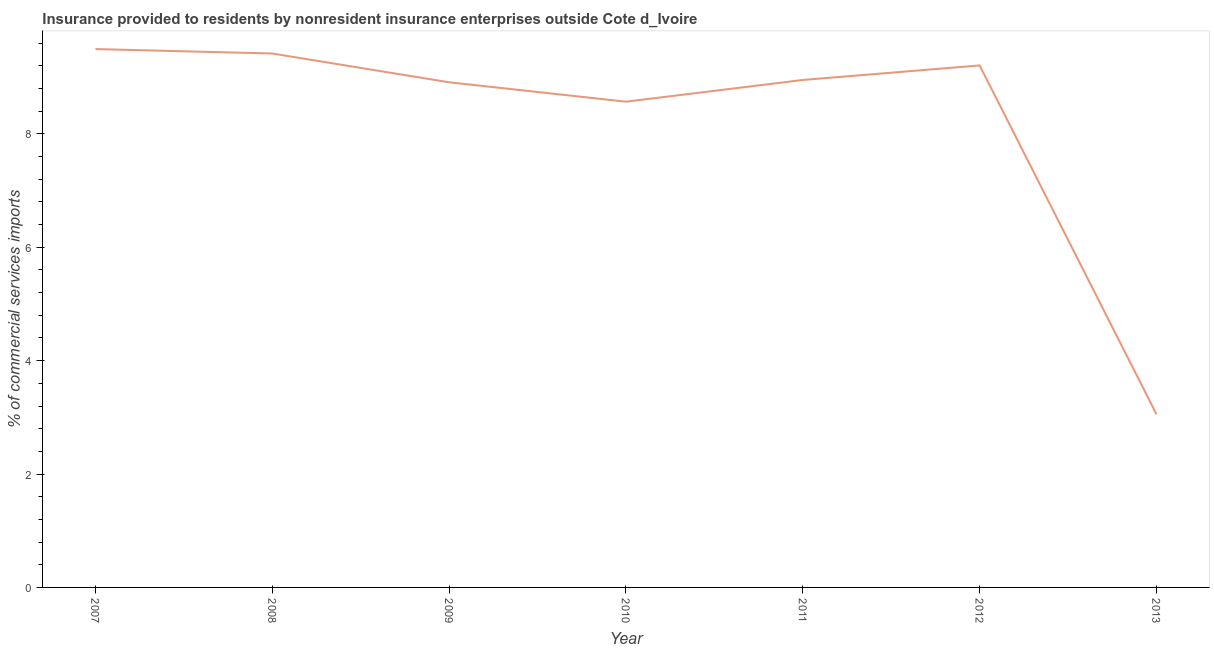What is the insurance provided by non-residents in 2011?
Provide a short and direct response. 8.95. Across all years, what is the maximum insurance provided by non-residents?
Provide a succinct answer. 9.5. Across all years, what is the minimum insurance provided by non-residents?
Your answer should be compact. 3.05. What is the sum of the insurance provided by non-residents?
Give a very brief answer. 57.6. What is the difference between the insurance provided by non-residents in 2010 and 2013?
Offer a very short reply. 5.51. What is the average insurance provided by non-residents per year?
Give a very brief answer. 8.23. What is the median insurance provided by non-residents?
Offer a terse response. 8.95. Do a majority of the years between 2007 and 2008 (inclusive) have insurance provided by non-residents greater than 4 %?
Provide a short and direct response. Yes. What is the ratio of the insurance provided by non-residents in 2007 to that in 2011?
Keep it short and to the point. 1.06. Is the difference between the insurance provided by non-residents in 2007 and 2013 greater than the difference between any two years?
Offer a very short reply. Yes. What is the difference between the highest and the second highest insurance provided by non-residents?
Your answer should be compact. 0.08. What is the difference between the highest and the lowest insurance provided by non-residents?
Offer a very short reply. 6.44. In how many years, is the insurance provided by non-residents greater than the average insurance provided by non-residents taken over all years?
Provide a succinct answer. 6. How many years are there in the graph?
Ensure brevity in your answer.  7. Are the values on the major ticks of Y-axis written in scientific E-notation?
Keep it short and to the point. No. Does the graph contain any zero values?
Keep it short and to the point. No. What is the title of the graph?
Provide a short and direct response. Insurance provided to residents by nonresident insurance enterprises outside Cote d_Ivoire. What is the label or title of the X-axis?
Your answer should be compact. Year. What is the label or title of the Y-axis?
Provide a short and direct response. % of commercial services imports. What is the % of commercial services imports of 2007?
Keep it short and to the point. 9.5. What is the % of commercial services imports of 2008?
Provide a succinct answer. 9.42. What is the % of commercial services imports of 2009?
Provide a short and direct response. 8.91. What is the % of commercial services imports of 2010?
Offer a terse response. 8.57. What is the % of commercial services imports of 2011?
Your answer should be compact. 8.95. What is the % of commercial services imports of 2012?
Your response must be concise. 9.21. What is the % of commercial services imports in 2013?
Your answer should be very brief. 3.05. What is the difference between the % of commercial services imports in 2007 and 2008?
Your response must be concise. 0.08. What is the difference between the % of commercial services imports in 2007 and 2009?
Provide a short and direct response. 0.59. What is the difference between the % of commercial services imports in 2007 and 2010?
Make the answer very short. 0.93. What is the difference between the % of commercial services imports in 2007 and 2011?
Your response must be concise. 0.54. What is the difference between the % of commercial services imports in 2007 and 2012?
Your answer should be very brief. 0.29. What is the difference between the % of commercial services imports in 2007 and 2013?
Offer a terse response. 6.44. What is the difference between the % of commercial services imports in 2008 and 2009?
Your answer should be compact. 0.51. What is the difference between the % of commercial services imports in 2008 and 2010?
Offer a very short reply. 0.85. What is the difference between the % of commercial services imports in 2008 and 2011?
Offer a very short reply. 0.47. What is the difference between the % of commercial services imports in 2008 and 2012?
Offer a terse response. 0.21. What is the difference between the % of commercial services imports in 2008 and 2013?
Offer a very short reply. 6.36. What is the difference between the % of commercial services imports in 2009 and 2010?
Your answer should be very brief. 0.34. What is the difference between the % of commercial services imports in 2009 and 2011?
Your response must be concise. -0.04. What is the difference between the % of commercial services imports in 2009 and 2012?
Offer a very short reply. -0.3. What is the difference between the % of commercial services imports in 2009 and 2013?
Your answer should be compact. 5.86. What is the difference between the % of commercial services imports in 2010 and 2011?
Keep it short and to the point. -0.38. What is the difference between the % of commercial services imports in 2010 and 2012?
Your answer should be compact. -0.64. What is the difference between the % of commercial services imports in 2010 and 2013?
Make the answer very short. 5.51. What is the difference between the % of commercial services imports in 2011 and 2012?
Make the answer very short. -0.26. What is the difference between the % of commercial services imports in 2011 and 2013?
Make the answer very short. 5.9. What is the difference between the % of commercial services imports in 2012 and 2013?
Your answer should be compact. 6.15. What is the ratio of the % of commercial services imports in 2007 to that in 2009?
Your response must be concise. 1.07. What is the ratio of the % of commercial services imports in 2007 to that in 2010?
Provide a succinct answer. 1.11. What is the ratio of the % of commercial services imports in 2007 to that in 2011?
Provide a succinct answer. 1.06. What is the ratio of the % of commercial services imports in 2007 to that in 2012?
Provide a short and direct response. 1.03. What is the ratio of the % of commercial services imports in 2007 to that in 2013?
Your response must be concise. 3.11. What is the ratio of the % of commercial services imports in 2008 to that in 2009?
Provide a short and direct response. 1.06. What is the ratio of the % of commercial services imports in 2008 to that in 2010?
Make the answer very short. 1.1. What is the ratio of the % of commercial services imports in 2008 to that in 2011?
Give a very brief answer. 1.05. What is the ratio of the % of commercial services imports in 2008 to that in 2013?
Your answer should be very brief. 3.08. What is the ratio of the % of commercial services imports in 2009 to that in 2010?
Offer a terse response. 1.04. What is the ratio of the % of commercial services imports in 2009 to that in 2013?
Your answer should be compact. 2.92. What is the ratio of the % of commercial services imports in 2010 to that in 2011?
Offer a terse response. 0.96. What is the ratio of the % of commercial services imports in 2010 to that in 2012?
Give a very brief answer. 0.93. What is the ratio of the % of commercial services imports in 2010 to that in 2013?
Your answer should be very brief. 2.81. What is the ratio of the % of commercial services imports in 2011 to that in 2012?
Your answer should be compact. 0.97. What is the ratio of the % of commercial services imports in 2011 to that in 2013?
Offer a terse response. 2.93. What is the ratio of the % of commercial services imports in 2012 to that in 2013?
Provide a short and direct response. 3.01. 